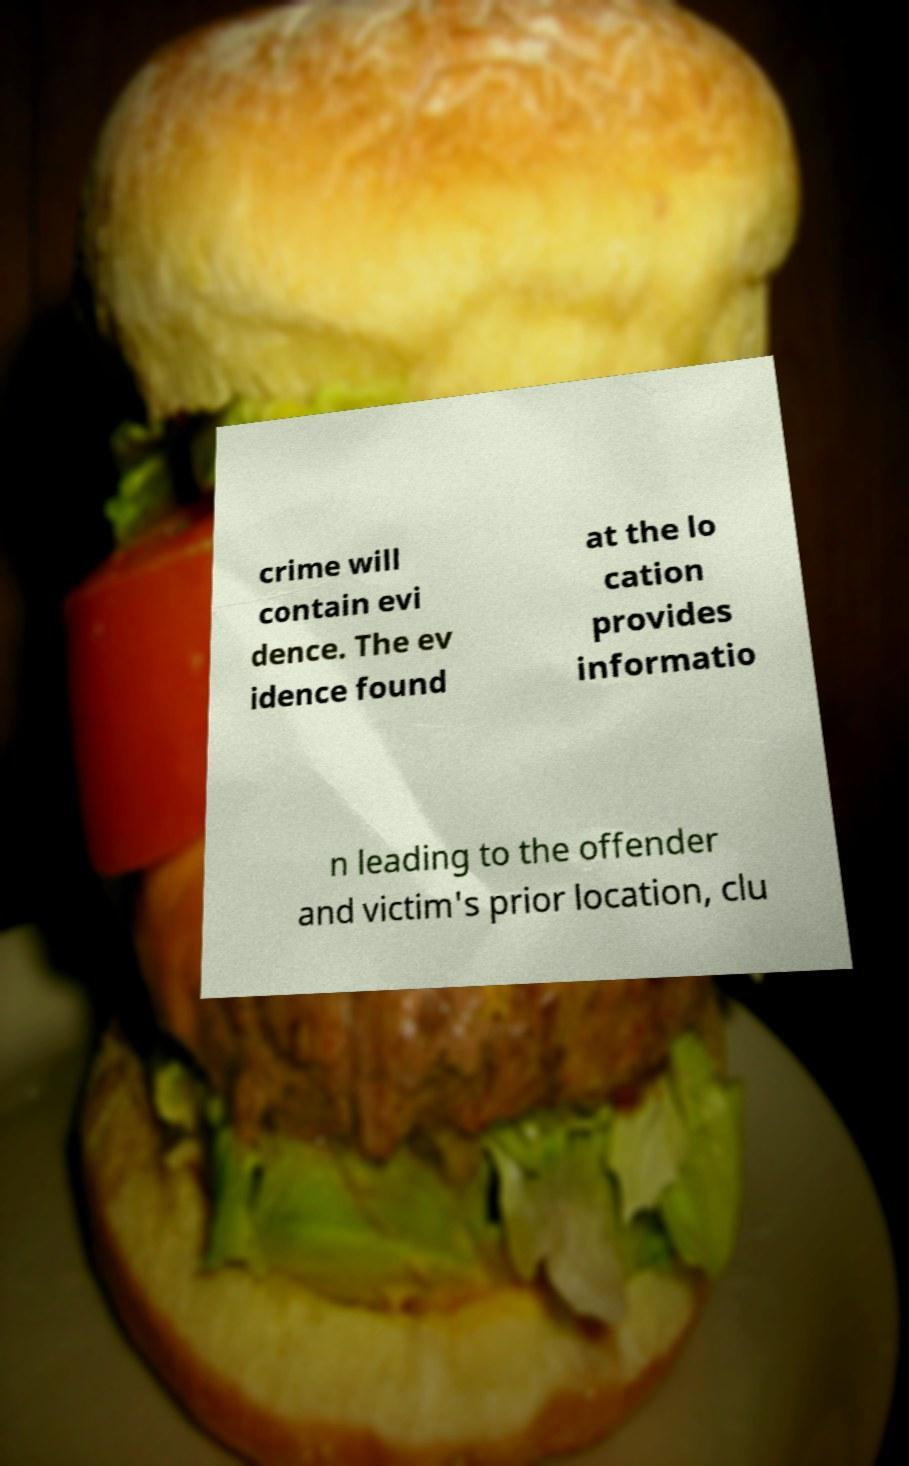For documentation purposes, I need the text within this image transcribed. Could you provide that? crime will contain evi dence. The ev idence found at the lo cation provides informatio n leading to the offender and victim's prior location, clu 